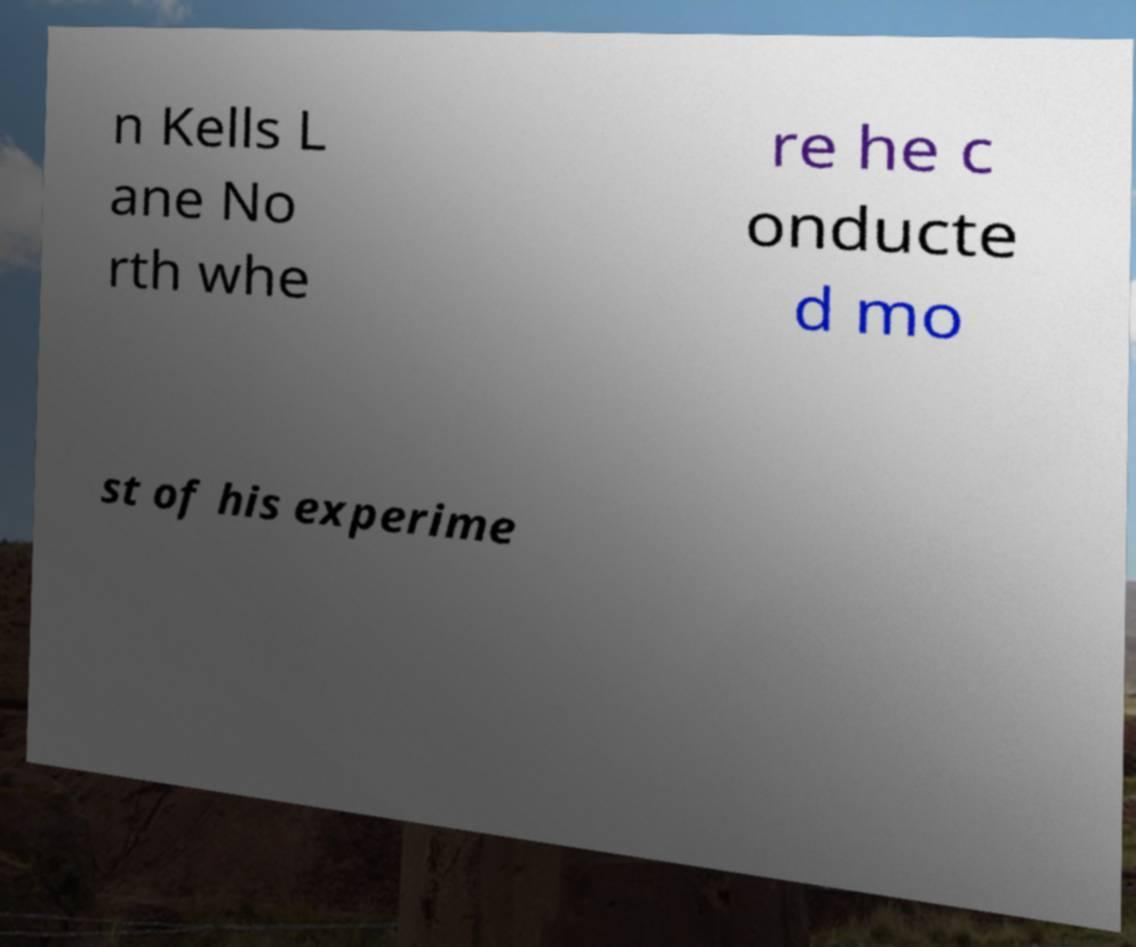Could you assist in decoding the text presented in this image and type it out clearly? n Kells L ane No rth whe re he c onducte d mo st of his experime 